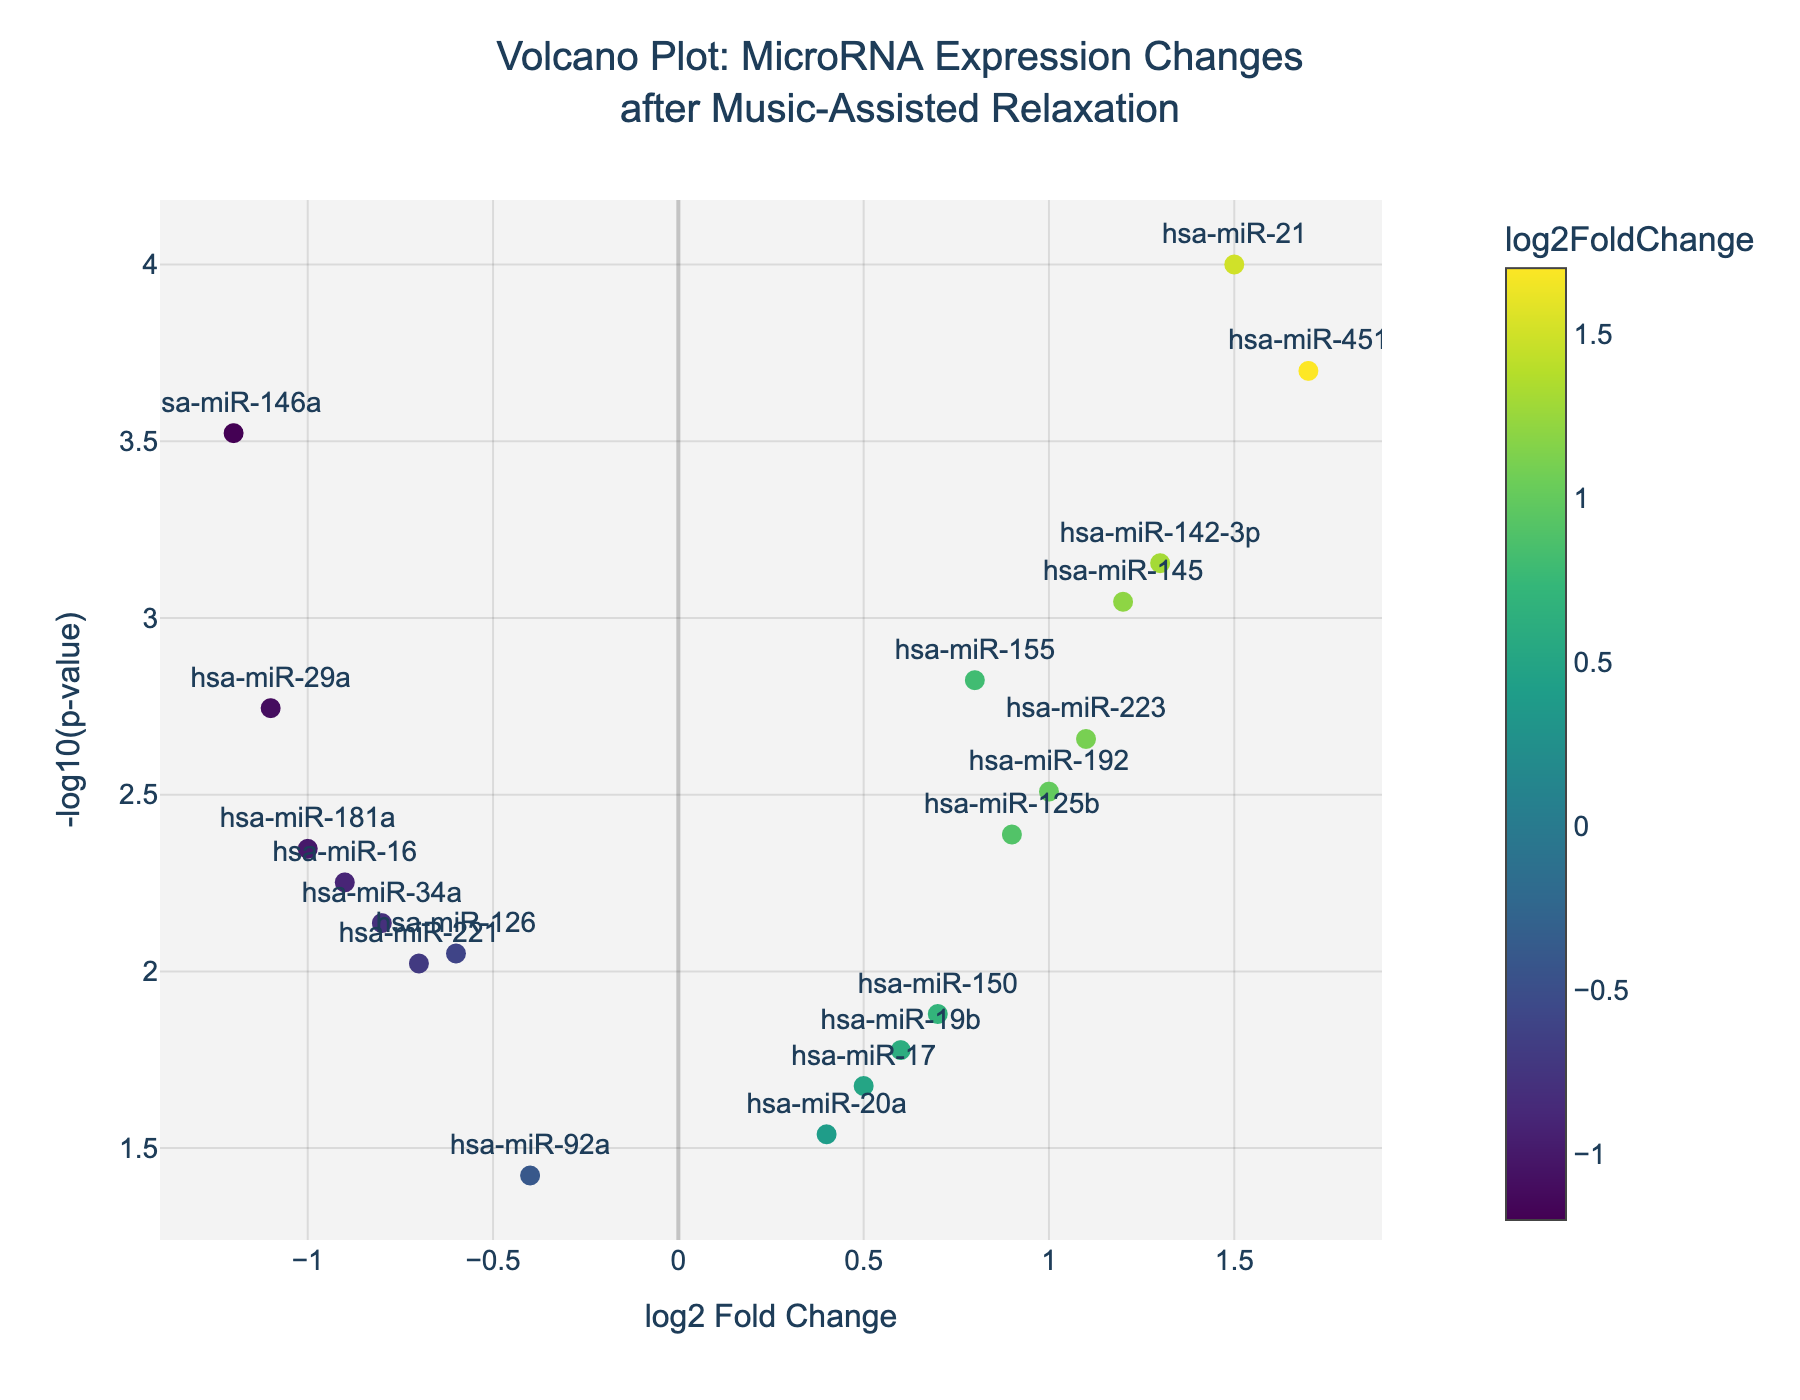How many miRNAs have a log2 fold change greater than 1? To find this, look at the x-axis (log2 Fold Change) and count the number of data points to the right of the line marked at 1. There are four miRNAs that meet this criterion.
Answer: 4 Which miRNA has the highest log2 fold change? To determine this, locate the point farthest to the right on the x-axis (log2 Fold Change). The miRNA at this point has the highest log2 fold change. It is hsa-miR-451 with a log2 fold change of 1.7.
Answer: hsa-miR-451 Which miRNA is most statistically significant? The most statistically significant miRNA is represented by the point highest on the y-axis (-log10(p-value)). This point corresponds to hsa-miR-21 with a p-value that translates to a very high -log10(p-value).
Answer: hsa-miR-21 How many miRNAs have a log2 fold change less than 0? To answer this, count the number of points to the left of 0 on the x-axis (log2 Fold Change). There are 10 miRNAs with log2 fold change less than 0.
Answer: 10 Which miRNA has the lowest p-value? The miRNA with the lowest p-value will be the point highest on the y-axis (-log10(p-value)). This point is hsa-miR-21 with the most statistically significant p-value of 0.0001.
Answer: hsa-miR-21 What is the log2 fold change for hsa-miR-145? Locate the point labeled hsa-miR-145 and note its position on the x-axis (log2 Fold Change). The log2 fold change for hsa-miR-145 is 1.2.
Answer: 1.2 How many miRNAs have a p-value less than 0.01? Convert the p-value threshold to -log10 scale: -log10(0.01) = 2. Count all points above this value on the y-axis. This includes all points with a -log10(p-value) greater than 2. There are 10 such miRNAs.
Answer: 10 Which miRNA has the lowest log2 fold change? Find the point farthest to the left on the x-axis (log2 Fold Change). This point corresponds to hsa-miR-146a with a log2 fold change of -1.2.
Answer: hsa-miR-146a What is the relationship between log2 fold change and -log10(p-value) for hsa-miR-142-3p? Locate the point for hsa-miR-142-3p and note its coordinates. The log2 fold change for hsa-miR-142-3p is 1.3, and the corresponding -log10(p-value) is around 3.15.
Answer: log2FC: 1.3, -log10(p): 3.15 